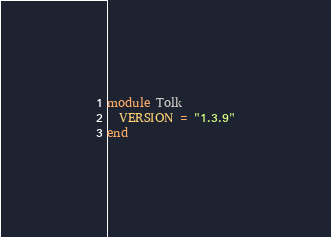Convert code to text. <code><loc_0><loc_0><loc_500><loc_500><_Ruby_>module Tolk
  VERSION = "1.3.9"
end
</code> 